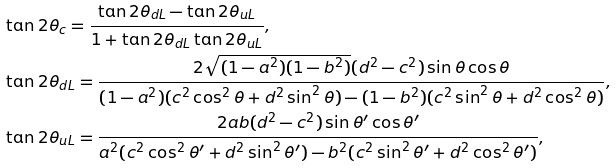<formula> <loc_0><loc_0><loc_500><loc_500>& \tan 2 \theta _ { c } = \frac { \tan 2 \theta _ { d L } - \tan 2 \theta _ { u L } } { 1 + \tan 2 \theta _ { d L } \tan 2 \theta _ { u L } } , \\ & \tan 2 \theta _ { d L } = \frac { 2 \sqrt { ( 1 - a ^ { 2 } ) ( 1 - b ^ { 2 } ) } ( d ^ { 2 } - c ^ { 2 } ) \sin \theta \cos \theta } { ( 1 - a ^ { 2 } ) ( c ^ { 2 } \cos ^ { 2 } \theta + d ^ { 2 } \sin ^ { 2 } \theta ) - ( 1 - b ^ { 2 } ) ( c ^ { 2 } \sin ^ { 2 } \theta + d ^ { 2 } \cos ^ { 2 } \theta ) } , \\ & \tan 2 \theta _ { u L } = \frac { 2 a b ( d ^ { 2 } - c ^ { 2 } ) \sin \theta ^ { \prime } \cos \theta ^ { \prime } } { a ^ { 2 } ( c ^ { 2 } \cos ^ { 2 } \theta ^ { \prime } + d ^ { 2 } \sin ^ { 2 } \theta ^ { \prime } ) - b ^ { 2 } ( c ^ { 2 } \sin ^ { 2 } \theta ^ { \prime } + d ^ { 2 } \cos ^ { 2 } \theta ^ { \prime } ) } ,</formula> 